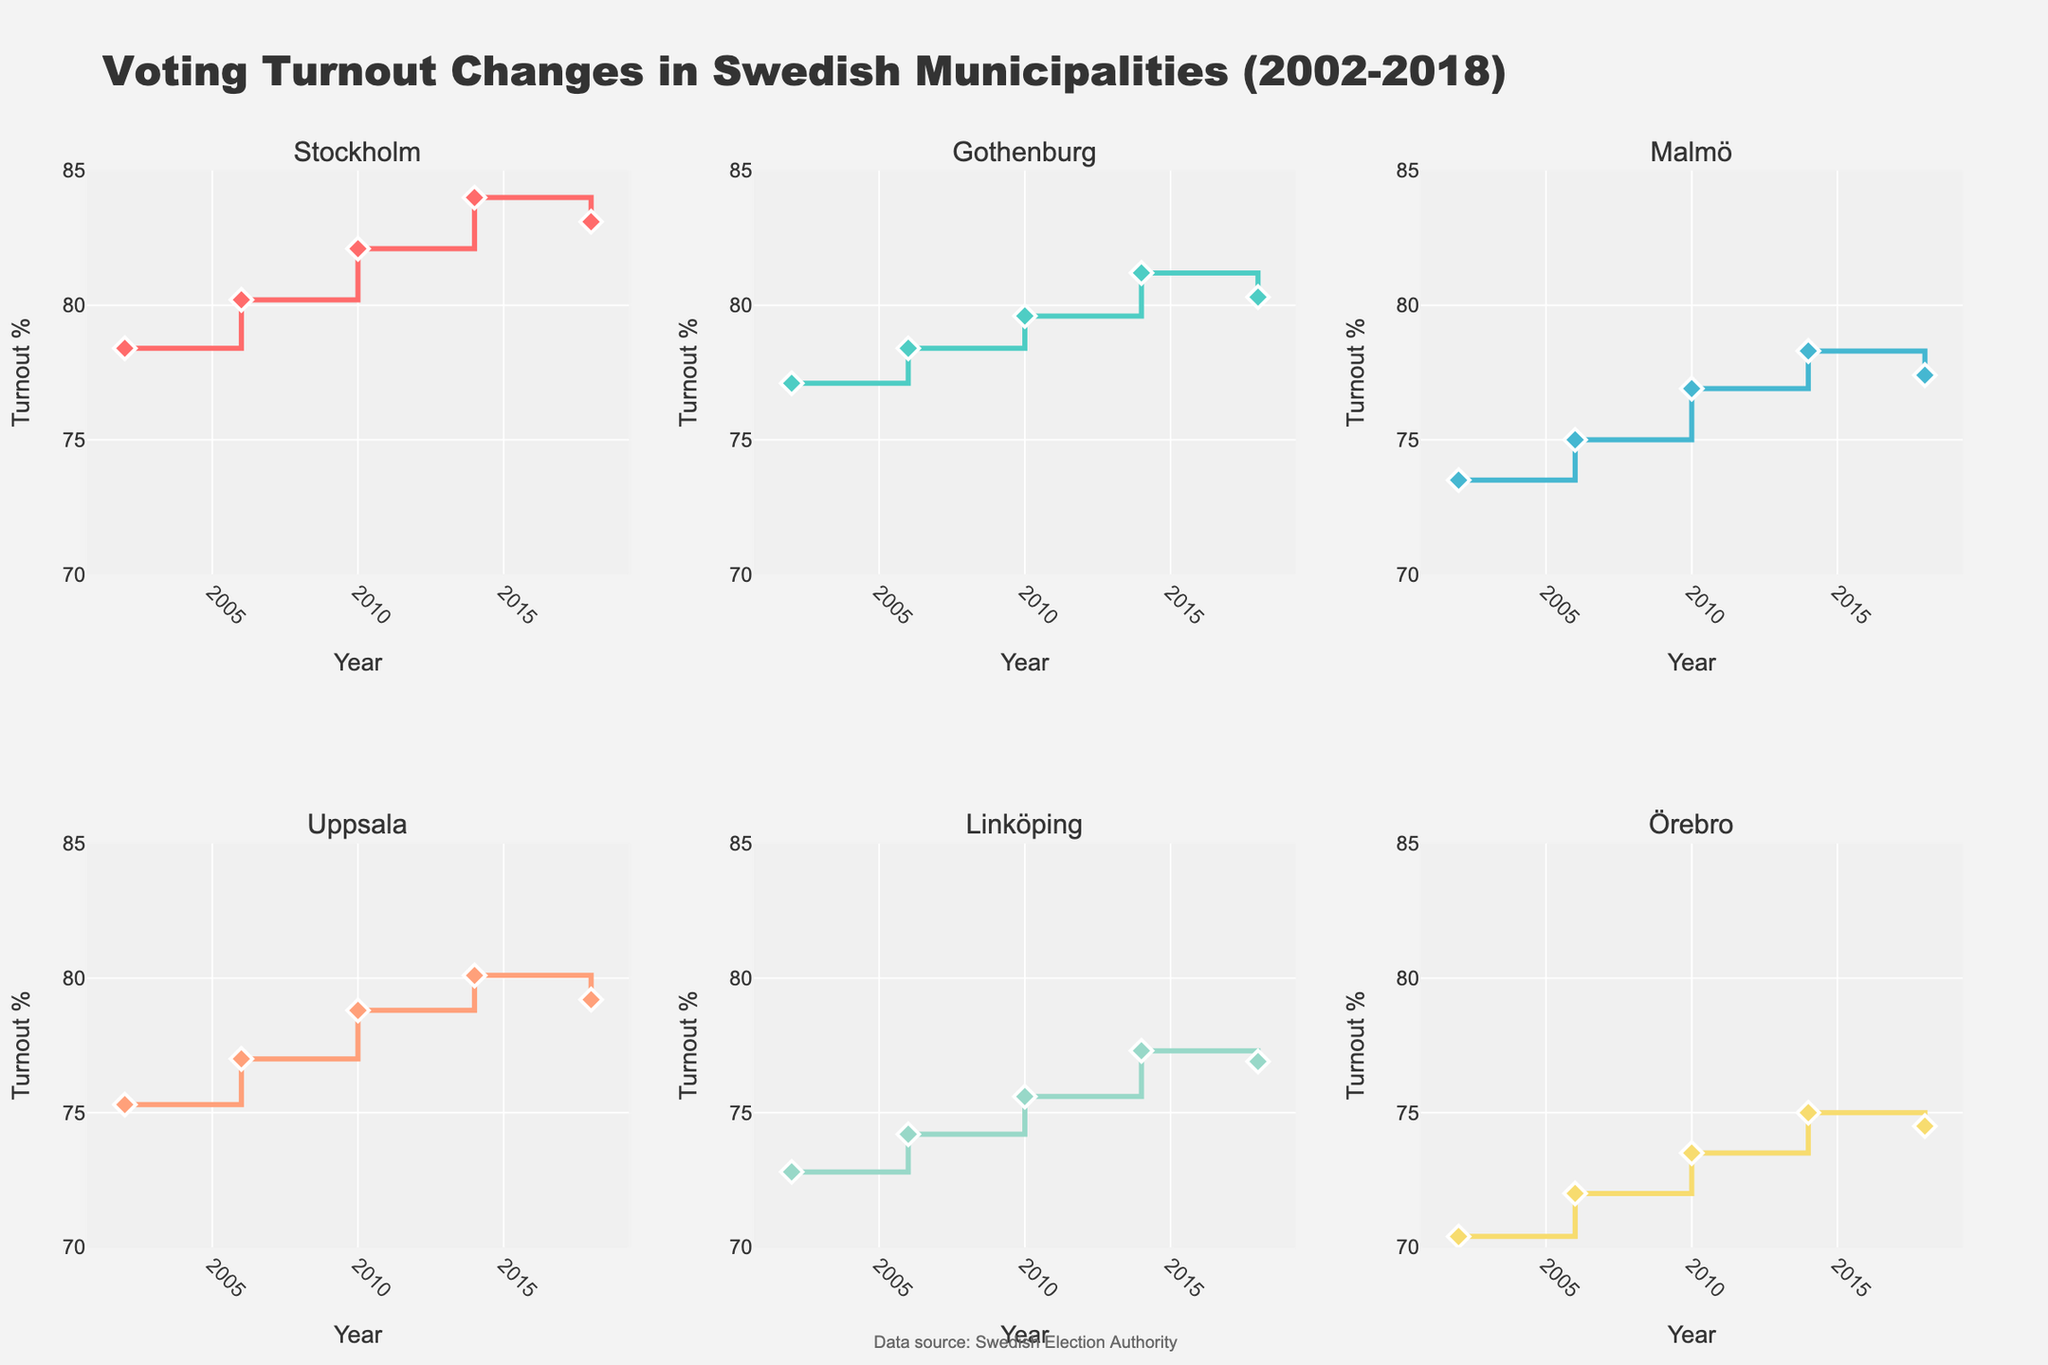What's the title of the figure? The title of the figure is located at the top and it summarizes what the figure is about in one concise statement.
Answer: Voting Turnout Changes in Swedish Municipalities (2002-2018) What are the x-axis and y-axis labels? The x-axis and y-axis labels are positioned along the respective axes and give context to the data points plotted. The x-axis is labeled with time intervals, and the y-axis represents the variable being measured.
Answer: The x-axis is labeled 'Year' and the y-axis is labeled 'Turnout %' Which municipality had the highest voter turnout percentage in 2018? To determine this, look at the y-values (Turnout Percentage) for the year 2018 in each subplot and identify the one with the highest value.
Answer: Stockholm (83.1%) Compare the voter turnout percentage changes between 2002 and 2018 for Stockholm and Malmö. Which municipality had a greater increase? Locate the data points for the years 2002 and 2018 in the subplots for both municipalities. Calculate the difference for both, and then compare the differences.
Answer: Stockholm: (83.1 - 78.4) = 4.7%, Malmö: (77.4 - 73.5) = 3.9%. Stockholm had a greater increase What is the trend in voter turnout for Gothenburg from 2002 to 2018? Observe the shape of the line in the Gothenburg subplot from 2002 to 2018. Assess whether it generally goes up, down, or stays the same.
Answer: The general trend is increasing; however, there is a slight decrease in 2018 What year did Uppsala reach its peak voter turnout percentage? Look at the line chart for Uppsala and identify the year when the y-value (Turnout Percentage) is at its highest point.
Answer: 2014 What was the average voter turnout percentage in Linköping between 2002 and 2018? Sum the voter turnout percentages for each recorded year for Linköping and then divide by the number of years.
Answer: (72.8 + 74.2 + 75.6 + 77.3 + 76.9) / 5 = 75.36% Which municipalities experienced a decrease in voter turnout percentage from 2014 to 2018? Check the subplots for all municipalities and compare the y-values (Turnout Percentage) between 2014 and 2018 to see which ones show a decrease.
Answer: Stockholm, Gothenburg, Malmö, Uppsala, and Örebro How many data points are there for each municipality? Count the number of data points (markers) in any one of the subplots; since it is a trend line over years, all should have the same number.
Answer: 5 data points What can be inferred from the changes in voter turnout for Örebro between 2002 and 2018? Observe the line chart for Örebro, noting the starting and ending points, as well as any fluctuations. Identify any overall trends, peaks, and declines.
Answer: Turnout increased initially but decreased following 2014, with a total increase from 70.4% to 74.5% 